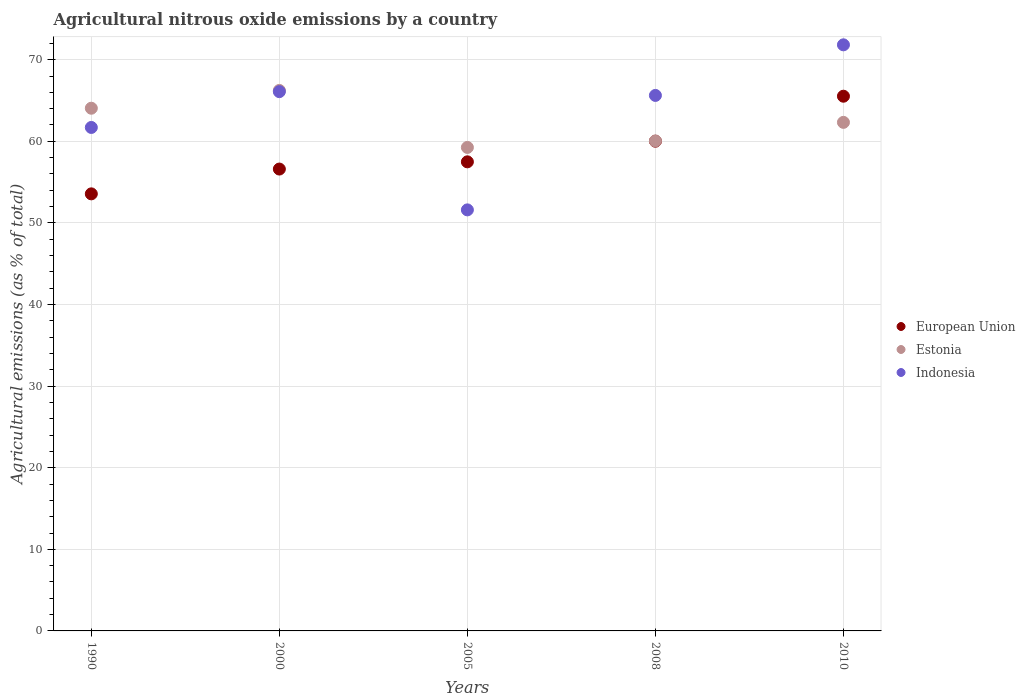What is the amount of agricultural nitrous oxide emitted in Estonia in 2000?
Offer a terse response. 66.24. Across all years, what is the maximum amount of agricultural nitrous oxide emitted in Estonia?
Your response must be concise. 66.24. Across all years, what is the minimum amount of agricultural nitrous oxide emitted in Estonia?
Provide a succinct answer. 59.25. In which year was the amount of agricultural nitrous oxide emitted in Indonesia maximum?
Your answer should be compact. 2010. What is the total amount of agricultural nitrous oxide emitted in Estonia in the graph?
Your response must be concise. 311.91. What is the difference between the amount of agricultural nitrous oxide emitted in Indonesia in 2000 and that in 2008?
Offer a terse response. 0.46. What is the difference between the amount of agricultural nitrous oxide emitted in Indonesia in 1990 and the amount of agricultural nitrous oxide emitted in European Union in 2008?
Offer a terse response. 1.69. What is the average amount of agricultural nitrous oxide emitted in Estonia per year?
Make the answer very short. 62.38. In the year 2005, what is the difference between the amount of agricultural nitrous oxide emitted in Estonia and amount of agricultural nitrous oxide emitted in Indonesia?
Your answer should be very brief. 7.65. What is the ratio of the amount of agricultural nitrous oxide emitted in European Union in 1990 to that in 2000?
Ensure brevity in your answer.  0.95. What is the difference between the highest and the second highest amount of agricultural nitrous oxide emitted in Indonesia?
Offer a terse response. 5.74. What is the difference between the highest and the lowest amount of agricultural nitrous oxide emitted in European Union?
Ensure brevity in your answer.  11.97. In how many years, is the amount of agricultural nitrous oxide emitted in Estonia greater than the average amount of agricultural nitrous oxide emitted in Estonia taken over all years?
Your response must be concise. 2. Is it the case that in every year, the sum of the amount of agricultural nitrous oxide emitted in European Union and amount of agricultural nitrous oxide emitted in Estonia  is greater than the amount of agricultural nitrous oxide emitted in Indonesia?
Provide a succinct answer. Yes. Does the amount of agricultural nitrous oxide emitted in Estonia monotonically increase over the years?
Ensure brevity in your answer.  No. How many dotlines are there?
Your answer should be compact. 3. How many years are there in the graph?
Your response must be concise. 5. What is the difference between two consecutive major ticks on the Y-axis?
Your answer should be compact. 10. Where does the legend appear in the graph?
Offer a very short reply. Center right. How are the legend labels stacked?
Your answer should be very brief. Vertical. What is the title of the graph?
Ensure brevity in your answer.  Agricultural nitrous oxide emissions by a country. Does "Aruba" appear as one of the legend labels in the graph?
Provide a succinct answer. No. What is the label or title of the X-axis?
Make the answer very short. Years. What is the label or title of the Y-axis?
Your answer should be compact. Agricultural emissions (as % of total). What is the Agricultural emissions (as % of total) in European Union in 1990?
Your answer should be very brief. 53.56. What is the Agricultural emissions (as % of total) of Estonia in 1990?
Your answer should be compact. 64.06. What is the Agricultural emissions (as % of total) in Indonesia in 1990?
Your answer should be compact. 61.7. What is the Agricultural emissions (as % of total) in European Union in 2000?
Your response must be concise. 56.6. What is the Agricultural emissions (as % of total) of Estonia in 2000?
Your answer should be very brief. 66.24. What is the Agricultural emissions (as % of total) in Indonesia in 2000?
Provide a short and direct response. 66.09. What is the Agricultural emissions (as % of total) in European Union in 2005?
Offer a very short reply. 57.49. What is the Agricultural emissions (as % of total) of Estonia in 2005?
Offer a terse response. 59.25. What is the Agricultural emissions (as % of total) in Indonesia in 2005?
Keep it short and to the point. 51.6. What is the Agricultural emissions (as % of total) in European Union in 2008?
Your answer should be compact. 60.01. What is the Agricultural emissions (as % of total) in Estonia in 2008?
Your response must be concise. 60.05. What is the Agricultural emissions (as % of total) of Indonesia in 2008?
Your response must be concise. 65.62. What is the Agricultural emissions (as % of total) of European Union in 2010?
Offer a very short reply. 65.53. What is the Agricultural emissions (as % of total) in Estonia in 2010?
Make the answer very short. 62.32. What is the Agricultural emissions (as % of total) of Indonesia in 2010?
Offer a very short reply. 71.83. Across all years, what is the maximum Agricultural emissions (as % of total) in European Union?
Your answer should be compact. 65.53. Across all years, what is the maximum Agricultural emissions (as % of total) of Estonia?
Give a very brief answer. 66.24. Across all years, what is the maximum Agricultural emissions (as % of total) in Indonesia?
Provide a short and direct response. 71.83. Across all years, what is the minimum Agricultural emissions (as % of total) of European Union?
Your response must be concise. 53.56. Across all years, what is the minimum Agricultural emissions (as % of total) of Estonia?
Give a very brief answer. 59.25. Across all years, what is the minimum Agricultural emissions (as % of total) in Indonesia?
Offer a very short reply. 51.6. What is the total Agricultural emissions (as % of total) of European Union in the graph?
Offer a terse response. 293.19. What is the total Agricultural emissions (as % of total) in Estonia in the graph?
Your answer should be very brief. 311.91. What is the total Agricultural emissions (as % of total) of Indonesia in the graph?
Provide a succinct answer. 316.83. What is the difference between the Agricultural emissions (as % of total) in European Union in 1990 and that in 2000?
Offer a very short reply. -3.04. What is the difference between the Agricultural emissions (as % of total) in Estonia in 1990 and that in 2000?
Offer a terse response. -2.18. What is the difference between the Agricultural emissions (as % of total) of Indonesia in 1990 and that in 2000?
Provide a succinct answer. -4.39. What is the difference between the Agricultural emissions (as % of total) of European Union in 1990 and that in 2005?
Your answer should be compact. -3.92. What is the difference between the Agricultural emissions (as % of total) of Estonia in 1990 and that in 2005?
Offer a terse response. 4.8. What is the difference between the Agricultural emissions (as % of total) of Indonesia in 1990 and that in 2005?
Give a very brief answer. 10.1. What is the difference between the Agricultural emissions (as % of total) in European Union in 1990 and that in 2008?
Ensure brevity in your answer.  -6.45. What is the difference between the Agricultural emissions (as % of total) of Estonia in 1990 and that in 2008?
Give a very brief answer. 4.01. What is the difference between the Agricultural emissions (as % of total) of Indonesia in 1990 and that in 2008?
Provide a succinct answer. -3.93. What is the difference between the Agricultural emissions (as % of total) of European Union in 1990 and that in 2010?
Provide a succinct answer. -11.97. What is the difference between the Agricultural emissions (as % of total) of Estonia in 1990 and that in 2010?
Offer a terse response. 1.73. What is the difference between the Agricultural emissions (as % of total) of Indonesia in 1990 and that in 2010?
Your answer should be very brief. -10.13. What is the difference between the Agricultural emissions (as % of total) in European Union in 2000 and that in 2005?
Keep it short and to the point. -0.89. What is the difference between the Agricultural emissions (as % of total) of Estonia in 2000 and that in 2005?
Your answer should be very brief. 6.98. What is the difference between the Agricultural emissions (as % of total) in Indonesia in 2000 and that in 2005?
Ensure brevity in your answer.  14.49. What is the difference between the Agricultural emissions (as % of total) in European Union in 2000 and that in 2008?
Your answer should be very brief. -3.41. What is the difference between the Agricultural emissions (as % of total) of Estonia in 2000 and that in 2008?
Provide a short and direct response. 6.19. What is the difference between the Agricultural emissions (as % of total) of Indonesia in 2000 and that in 2008?
Make the answer very short. 0.46. What is the difference between the Agricultural emissions (as % of total) of European Union in 2000 and that in 2010?
Your answer should be very brief. -8.93. What is the difference between the Agricultural emissions (as % of total) of Estonia in 2000 and that in 2010?
Your response must be concise. 3.91. What is the difference between the Agricultural emissions (as % of total) of Indonesia in 2000 and that in 2010?
Keep it short and to the point. -5.74. What is the difference between the Agricultural emissions (as % of total) of European Union in 2005 and that in 2008?
Your response must be concise. -2.53. What is the difference between the Agricultural emissions (as % of total) in Estonia in 2005 and that in 2008?
Your response must be concise. -0.79. What is the difference between the Agricultural emissions (as % of total) of Indonesia in 2005 and that in 2008?
Offer a very short reply. -14.03. What is the difference between the Agricultural emissions (as % of total) of European Union in 2005 and that in 2010?
Make the answer very short. -8.04. What is the difference between the Agricultural emissions (as % of total) of Estonia in 2005 and that in 2010?
Your answer should be very brief. -3.07. What is the difference between the Agricultural emissions (as % of total) of Indonesia in 2005 and that in 2010?
Your response must be concise. -20.23. What is the difference between the Agricultural emissions (as % of total) of European Union in 2008 and that in 2010?
Offer a terse response. -5.51. What is the difference between the Agricultural emissions (as % of total) in Estonia in 2008 and that in 2010?
Make the answer very short. -2.28. What is the difference between the Agricultural emissions (as % of total) in Indonesia in 2008 and that in 2010?
Provide a succinct answer. -6.2. What is the difference between the Agricultural emissions (as % of total) in European Union in 1990 and the Agricultural emissions (as % of total) in Estonia in 2000?
Keep it short and to the point. -12.68. What is the difference between the Agricultural emissions (as % of total) in European Union in 1990 and the Agricultural emissions (as % of total) in Indonesia in 2000?
Ensure brevity in your answer.  -12.53. What is the difference between the Agricultural emissions (as % of total) of Estonia in 1990 and the Agricultural emissions (as % of total) of Indonesia in 2000?
Make the answer very short. -2.03. What is the difference between the Agricultural emissions (as % of total) in European Union in 1990 and the Agricultural emissions (as % of total) in Estonia in 2005?
Give a very brief answer. -5.69. What is the difference between the Agricultural emissions (as % of total) in European Union in 1990 and the Agricultural emissions (as % of total) in Indonesia in 2005?
Your answer should be compact. 1.96. What is the difference between the Agricultural emissions (as % of total) of Estonia in 1990 and the Agricultural emissions (as % of total) of Indonesia in 2005?
Ensure brevity in your answer.  12.46. What is the difference between the Agricultural emissions (as % of total) of European Union in 1990 and the Agricultural emissions (as % of total) of Estonia in 2008?
Your answer should be compact. -6.48. What is the difference between the Agricultural emissions (as % of total) in European Union in 1990 and the Agricultural emissions (as % of total) in Indonesia in 2008?
Provide a short and direct response. -12.06. What is the difference between the Agricultural emissions (as % of total) of Estonia in 1990 and the Agricultural emissions (as % of total) of Indonesia in 2008?
Keep it short and to the point. -1.57. What is the difference between the Agricultural emissions (as % of total) of European Union in 1990 and the Agricultural emissions (as % of total) of Estonia in 2010?
Your answer should be compact. -8.76. What is the difference between the Agricultural emissions (as % of total) of European Union in 1990 and the Agricultural emissions (as % of total) of Indonesia in 2010?
Give a very brief answer. -18.26. What is the difference between the Agricultural emissions (as % of total) of Estonia in 1990 and the Agricultural emissions (as % of total) of Indonesia in 2010?
Provide a succinct answer. -7.77. What is the difference between the Agricultural emissions (as % of total) of European Union in 2000 and the Agricultural emissions (as % of total) of Estonia in 2005?
Offer a terse response. -2.65. What is the difference between the Agricultural emissions (as % of total) of European Union in 2000 and the Agricultural emissions (as % of total) of Indonesia in 2005?
Provide a succinct answer. 5. What is the difference between the Agricultural emissions (as % of total) in Estonia in 2000 and the Agricultural emissions (as % of total) in Indonesia in 2005?
Your answer should be compact. 14.64. What is the difference between the Agricultural emissions (as % of total) of European Union in 2000 and the Agricultural emissions (as % of total) of Estonia in 2008?
Keep it short and to the point. -3.44. What is the difference between the Agricultural emissions (as % of total) in European Union in 2000 and the Agricultural emissions (as % of total) in Indonesia in 2008?
Offer a terse response. -9.02. What is the difference between the Agricultural emissions (as % of total) of Estonia in 2000 and the Agricultural emissions (as % of total) of Indonesia in 2008?
Ensure brevity in your answer.  0.61. What is the difference between the Agricultural emissions (as % of total) of European Union in 2000 and the Agricultural emissions (as % of total) of Estonia in 2010?
Keep it short and to the point. -5.72. What is the difference between the Agricultural emissions (as % of total) in European Union in 2000 and the Agricultural emissions (as % of total) in Indonesia in 2010?
Your answer should be very brief. -15.22. What is the difference between the Agricultural emissions (as % of total) in Estonia in 2000 and the Agricultural emissions (as % of total) in Indonesia in 2010?
Your answer should be compact. -5.59. What is the difference between the Agricultural emissions (as % of total) of European Union in 2005 and the Agricultural emissions (as % of total) of Estonia in 2008?
Your answer should be compact. -2.56. What is the difference between the Agricultural emissions (as % of total) of European Union in 2005 and the Agricultural emissions (as % of total) of Indonesia in 2008?
Provide a short and direct response. -8.14. What is the difference between the Agricultural emissions (as % of total) of Estonia in 2005 and the Agricultural emissions (as % of total) of Indonesia in 2008?
Offer a very short reply. -6.37. What is the difference between the Agricultural emissions (as % of total) in European Union in 2005 and the Agricultural emissions (as % of total) in Estonia in 2010?
Your response must be concise. -4.84. What is the difference between the Agricultural emissions (as % of total) of European Union in 2005 and the Agricultural emissions (as % of total) of Indonesia in 2010?
Your answer should be very brief. -14.34. What is the difference between the Agricultural emissions (as % of total) in Estonia in 2005 and the Agricultural emissions (as % of total) in Indonesia in 2010?
Your response must be concise. -12.57. What is the difference between the Agricultural emissions (as % of total) of European Union in 2008 and the Agricultural emissions (as % of total) of Estonia in 2010?
Provide a succinct answer. -2.31. What is the difference between the Agricultural emissions (as % of total) of European Union in 2008 and the Agricultural emissions (as % of total) of Indonesia in 2010?
Provide a short and direct response. -11.81. What is the difference between the Agricultural emissions (as % of total) in Estonia in 2008 and the Agricultural emissions (as % of total) in Indonesia in 2010?
Offer a terse response. -11.78. What is the average Agricultural emissions (as % of total) of European Union per year?
Keep it short and to the point. 58.64. What is the average Agricultural emissions (as % of total) of Estonia per year?
Provide a succinct answer. 62.38. What is the average Agricultural emissions (as % of total) in Indonesia per year?
Give a very brief answer. 63.37. In the year 1990, what is the difference between the Agricultural emissions (as % of total) in European Union and Agricultural emissions (as % of total) in Estonia?
Provide a short and direct response. -10.49. In the year 1990, what is the difference between the Agricultural emissions (as % of total) in European Union and Agricultural emissions (as % of total) in Indonesia?
Ensure brevity in your answer.  -8.14. In the year 1990, what is the difference between the Agricultural emissions (as % of total) in Estonia and Agricultural emissions (as % of total) in Indonesia?
Keep it short and to the point. 2.36. In the year 2000, what is the difference between the Agricultural emissions (as % of total) in European Union and Agricultural emissions (as % of total) in Estonia?
Your response must be concise. -9.64. In the year 2000, what is the difference between the Agricultural emissions (as % of total) in European Union and Agricultural emissions (as % of total) in Indonesia?
Give a very brief answer. -9.49. In the year 2000, what is the difference between the Agricultural emissions (as % of total) of Estonia and Agricultural emissions (as % of total) of Indonesia?
Offer a terse response. 0.15. In the year 2005, what is the difference between the Agricultural emissions (as % of total) in European Union and Agricultural emissions (as % of total) in Estonia?
Your response must be concise. -1.77. In the year 2005, what is the difference between the Agricultural emissions (as % of total) of European Union and Agricultural emissions (as % of total) of Indonesia?
Offer a very short reply. 5.89. In the year 2005, what is the difference between the Agricultural emissions (as % of total) in Estonia and Agricultural emissions (as % of total) in Indonesia?
Offer a terse response. 7.65. In the year 2008, what is the difference between the Agricultural emissions (as % of total) in European Union and Agricultural emissions (as % of total) in Estonia?
Keep it short and to the point. -0.03. In the year 2008, what is the difference between the Agricultural emissions (as % of total) in European Union and Agricultural emissions (as % of total) in Indonesia?
Your answer should be compact. -5.61. In the year 2008, what is the difference between the Agricultural emissions (as % of total) of Estonia and Agricultural emissions (as % of total) of Indonesia?
Your response must be concise. -5.58. In the year 2010, what is the difference between the Agricultural emissions (as % of total) of European Union and Agricultural emissions (as % of total) of Estonia?
Ensure brevity in your answer.  3.2. In the year 2010, what is the difference between the Agricultural emissions (as % of total) in European Union and Agricultural emissions (as % of total) in Indonesia?
Give a very brief answer. -6.3. In the year 2010, what is the difference between the Agricultural emissions (as % of total) of Estonia and Agricultural emissions (as % of total) of Indonesia?
Your answer should be very brief. -9.5. What is the ratio of the Agricultural emissions (as % of total) in European Union in 1990 to that in 2000?
Keep it short and to the point. 0.95. What is the ratio of the Agricultural emissions (as % of total) of Estonia in 1990 to that in 2000?
Give a very brief answer. 0.97. What is the ratio of the Agricultural emissions (as % of total) in Indonesia in 1990 to that in 2000?
Give a very brief answer. 0.93. What is the ratio of the Agricultural emissions (as % of total) in European Union in 1990 to that in 2005?
Your response must be concise. 0.93. What is the ratio of the Agricultural emissions (as % of total) of Estonia in 1990 to that in 2005?
Your answer should be very brief. 1.08. What is the ratio of the Agricultural emissions (as % of total) in Indonesia in 1990 to that in 2005?
Make the answer very short. 1.2. What is the ratio of the Agricultural emissions (as % of total) of European Union in 1990 to that in 2008?
Offer a very short reply. 0.89. What is the ratio of the Agricultural emissions (as % of total) in Estonia in 1990 to that in 2008?
Your answer should be very brief. 1.07. What is the ratio of the Agricultural emissions (as % of total) in Indonesia in 1990 to that in 2008?
Ensure brevity in your answer.  0.94. What is the ratio of the Agricultural emissions (as % of total) of European Union in 1990 to that in 2010?
Provide a short and direct response. 0.82. What is the ratio of the Agricultural emissions (as % of total) of Estonia in 1990 to that in 2010?
Offer a terse response. 1.03. What is the ratio of the Agricultural emissions (as % of total) of Indonesia in 1990 to that in 2010?
Provide a succinct answer. 0.86. What is the ratio of the Agricultural emissions (as % of total) in European Union in 2000 to that in 2005?
Offer a terse response. 0.98. What is the ratio of the Agricultural emissions (as % of total) of Estonia in 2000 to that in 2005?
Ensure brevity in your answer.  1.12. What is the ratio of the Agricultural emissions (as % of total) in Indonesia in 2000 to that in 2005?
Provide a succinct answer. 1.28. What is the ratio of the Agricultural emissions (as % of total) in European Union in 2000 to that in 2008?
Provide a succinct answer. 0.94. What is the ratio of the Agricultural emissions (as % of total) of Estonia in 2000 to that in 2008?
Your answer should be compact. 1.1. What is the ratio of the Agricultural emissions (as % of total) of Indonesia in 2000 to that in 2008?
Offer a very short reply. 1.01. What is the ratio of the Agricultural emissions (as % of total) in European Union in 2000 to that in 2010?
Ensure brevity in your answer.  0.86. What is the ratio of the Agricultural emissions (as % of total) of Estonia in 2000 to that in 2010?
Your answer should be very brief. 1.06. What is the ratio of the Agricultural emissions (as % of total) in Indonesia in 2000 to that in 2010?
Your answer should be very brief. 0.92. What is the ratio of the Agricultural emissions (as % of total) of European Union in 2005 to that in 2008?
Your answer should be compact. 0.96. What is the ratio of the Agricultural emissions (as % of total) in Indonesia in 2005 to that in 2008?
Provide a short and direct response. 0.79. What is the ratio of the Agricultural emissions (as % of total) of European Union in 2005 to that in 2010?
Your response must be concise. 0.88. What is the ratio of the Agricultural emissions (as % of total) of Estonia in 2005 to that in 2010?
Provide a short and direct response. 0.95. What is the ratio of the Agricultural emissions (as % of total) of Indonesia in 2005 to that in 2010?
Ensure brevity in your answer.  0.72. What is the ratio of the Agricultural emissions (as % of total) in European Union in 2008 to that in 2010?
Provide a succinct answer. 0.92. What is the ratio of the Agricultural emissions (as % of total) of Estonia in 2008 to that in 2010?
Offer a terse response. 0.96. What is the ratio of the Agricultural emissions (as % of total) of Indonesia in 2008 to that in 2010?
Make the answer very short. 0.91. What is the difference between the highest and the second highest Agricultural emissions (as % of total) in European Union?
Provide a succinct answer. 5.51. What is the difference between the highest and the second highest Agricultural emissions (as % of total) of Estonia?
Make the answer very short. 2.18. What is the difference between the highest and the second highest Agricultural emissions (as % of total) in Indonesia?
Your response must be concise. 5.74. What is the difference between the highest and the lowest Agricultural emissions (as % of total) in European Union?
Provide a succinct answer. 11.97. What is the difference between the highest and the lowest Agricultural emissions (as % of total) of Estonia?
Your answer should be compact. 6.98. What is the difference between the highest and the lowest Agricultural emissions (as % of total) of Indonesia?
Your answer should be compact. 20.23. 